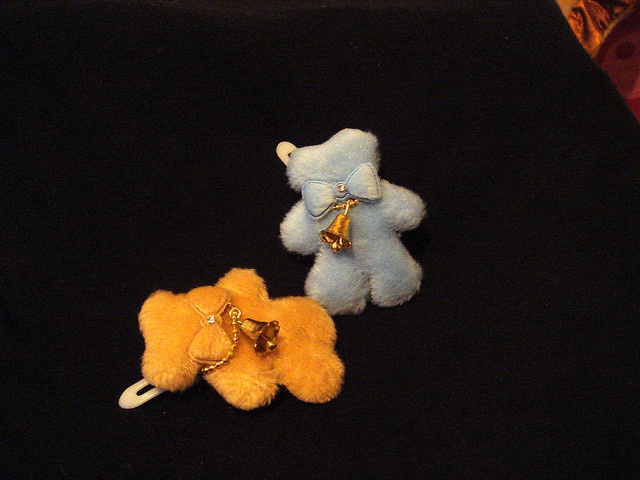Describe the objects in this image and their specific colors. I can see teddy bear in black, orange, and red tones, teddy bear in black, darkgray, tan, gray, and beige tones, tie in black, orange, and red tones, and tie in black, darkgray, and tan tones in this image. 